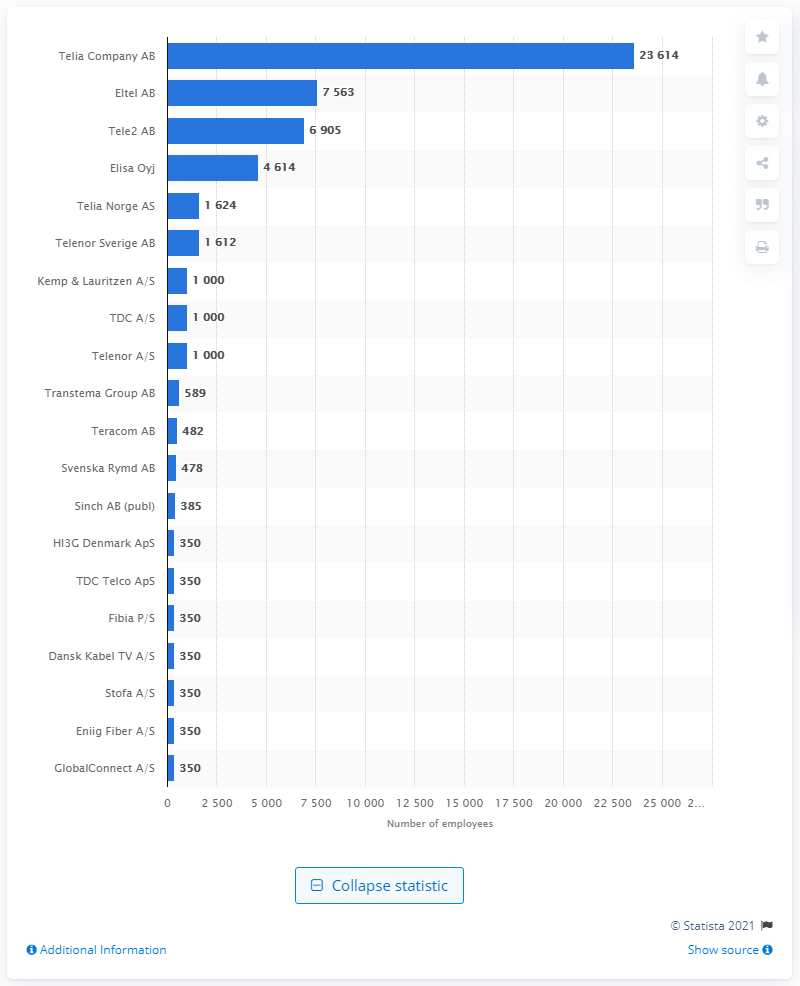Highlight a few significant elements in this photo. Eltel AB, a company based in the Nordics, is ranked second with approximately 7 thousand employees. As of May 2020, Telia Company AB was the telecommunications company in the Nordics with the most number of employees. 